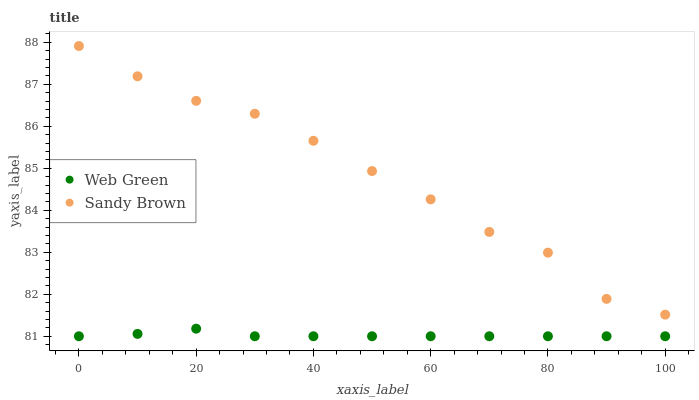Does Web Green have the minimum area under the curve?
Answer yes or no. Yes. Does Sandy Brown have the maximum area under the curve?
Answer yes or no. Yes. Does Web Green have the maximum area under the curve?
Answer yes or no. No. Is Web Green the smoothest?
Answer yes or no. Yes. Is Sandy Brown the roughest?
Answer yes or no. Yes. Is Web Green the roughest?
Answer yes or no. No. Does Web Green have the lowest value?
Answer yes or no. Yes. Does Sandy Brown have the highest value?
Answer yes or no. Yes. Does Web Green have the highest value?
Answer yes or no. No. Is Web Green less than Sandy Brown?
Answer yes or no. Yes. Is Sandy Brown greater than Web Green?
Answer yes or no. Yes. Does Web Green intersect Sandy Brown?
Answer yes or no. No. 